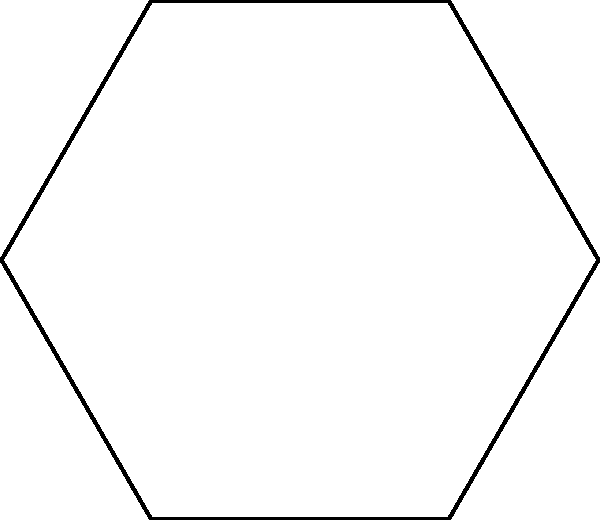In a Broadway theater, the stage is designed as a regular hexagon to allow for versatile performances. If an actor stands at the center of this hexagonal stage and rotates, through how many degrees must they turn to reach their original position? To solve this problem, let's consider the symmetry properties of a regular hexagon:

1. A regular hexagon has 6 vertices and 6 lines of symmetry.
2. Each line of symmetry passes through the center and either a vertex or the midpoint of a side.
3. The angle between any two adjacent lines of symmetry is constant.

To calculate this angle:

4. The total angle around the center point is 360°.
5. There are 6 equal sections in the hexagon.
6. Therefore, the angle for each section is: $360^\circ \div 6 = 60^\circ$

This means that rotating by 60° will bring you to the next equivalent position. To return to the original position:

7. The actor needs to complete a full rotation.
8. A full rotation is $360^\circ$.

Thus, the actor must rotate through $360^\circ$ to reach their original position.
Answer: $360^\circ$ 